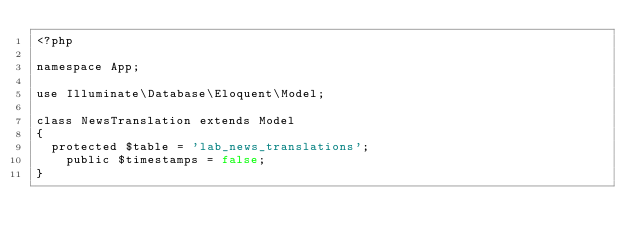Convert code to text. <code><loc_0><loc_0><loc_500><loc_500><_PHP_><?php

namespace App;

use Illuminate\Database\Eloquent\Model;

class NewsTranslation extends Model
{
	protected $table = 'lab_news_translations';
    public $timestamps = false;
}
</code> 